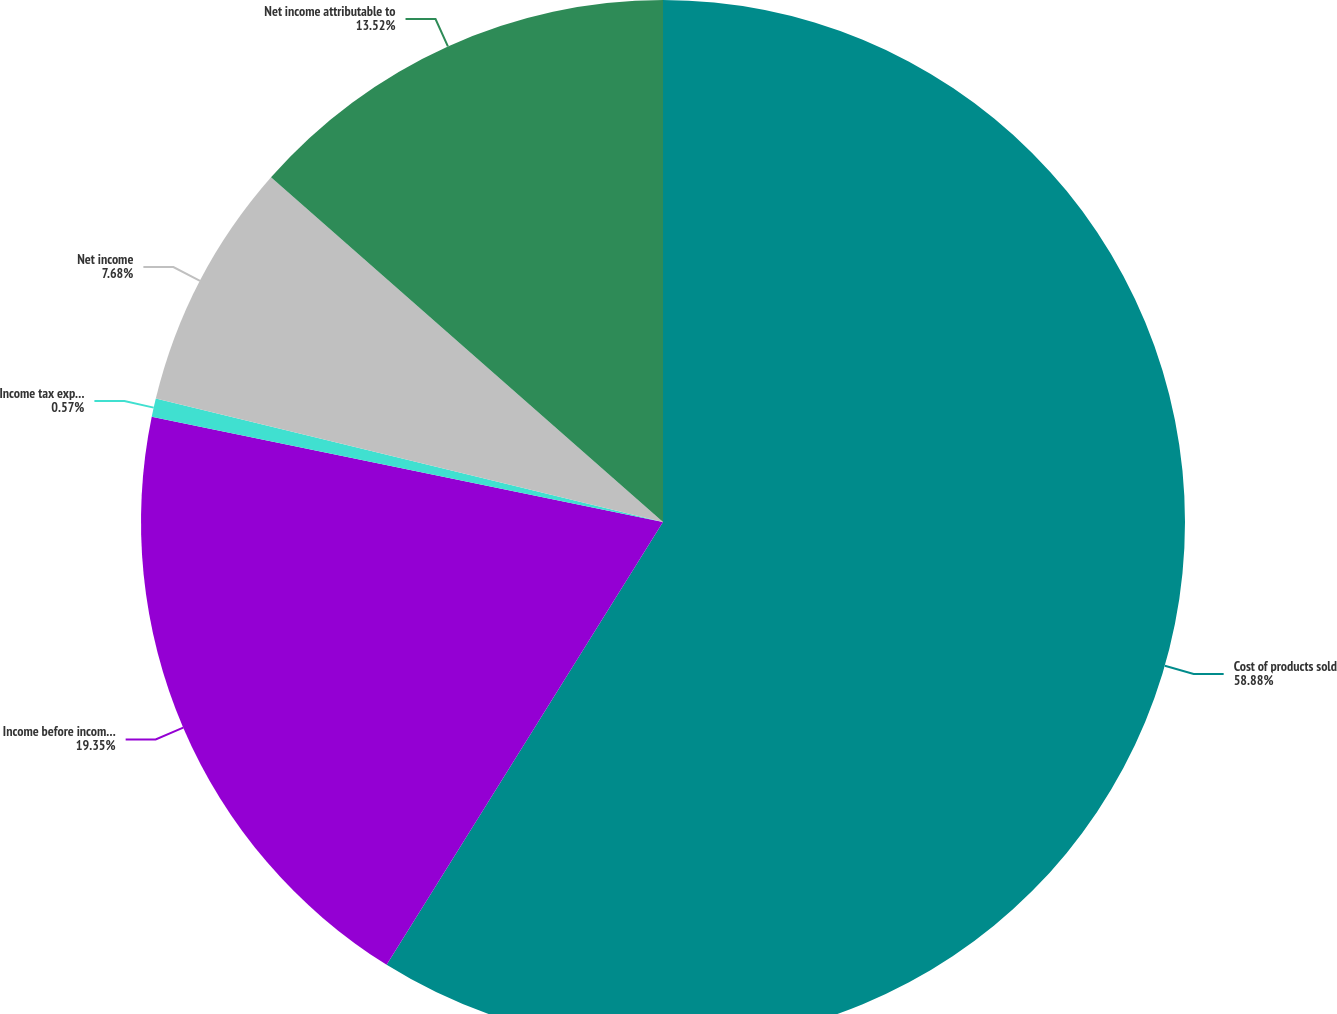<chart> <loc_0><loc_0><loc_500><loc_500><pie_chart><fcel>Cost of products sold<fcel>Income before income taxes<fcel>Income tax expense<fcel>Net income<fcel>Net income attributable to<nl><fcel>58.88%<fcel>19.35%<fcel>0.57%<fcel>7.68%<fcel>13.52%<nl></chart> 